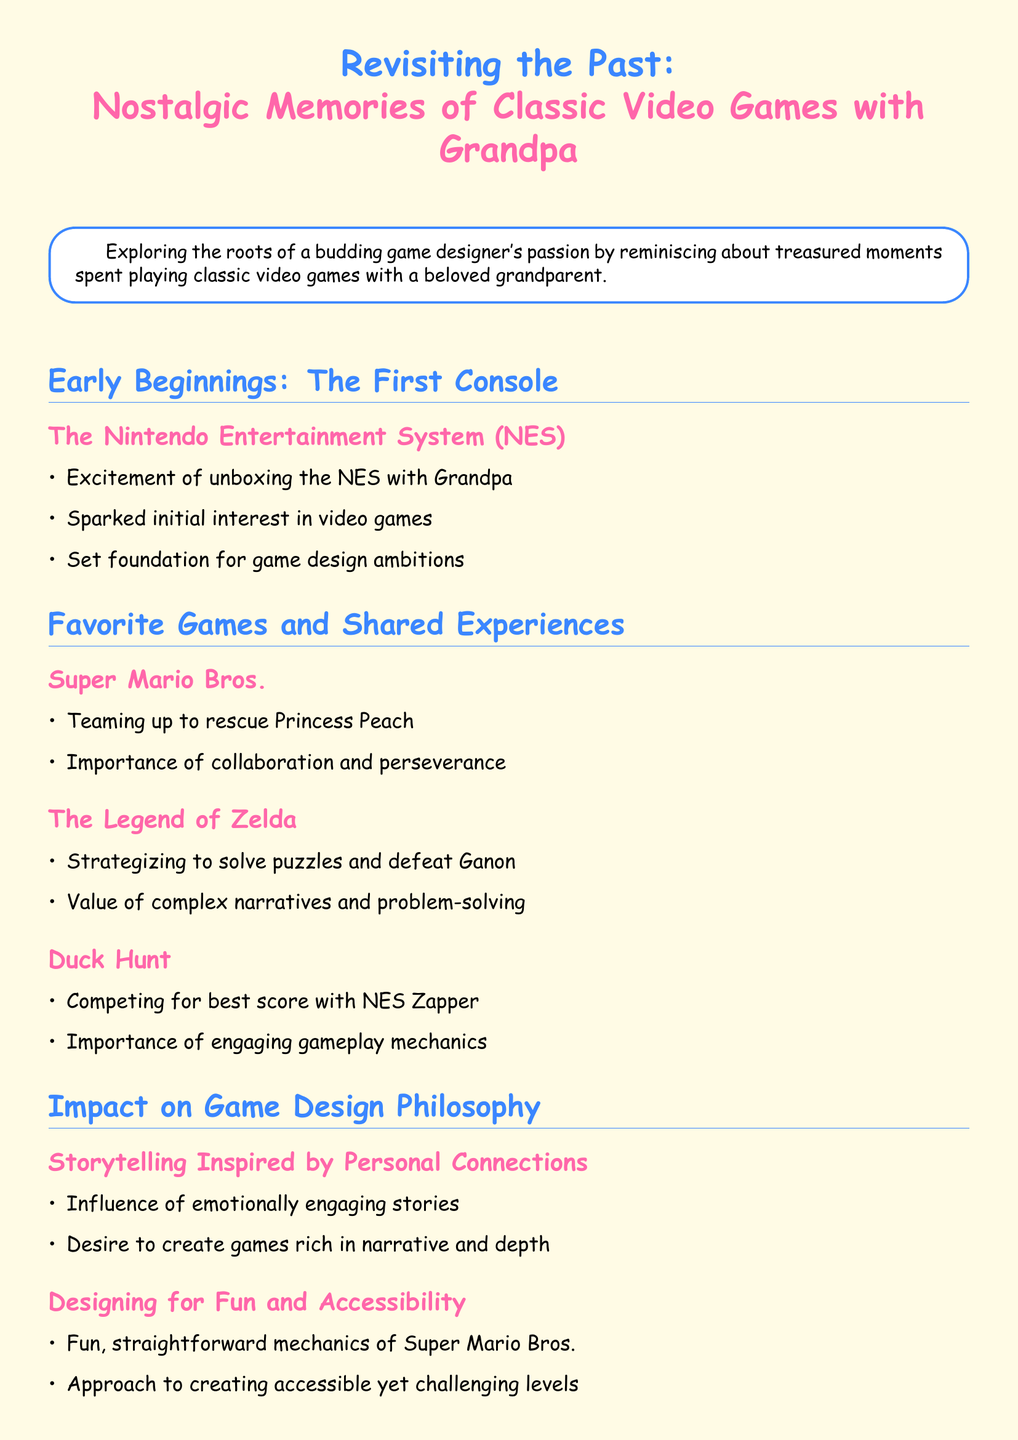What console sparked initial interest in video games? The document states that the Nintendo Entertainment System (NES) sparked initial interest in video games.
Answer: NES What game did you team up with Grandpa to rescue Princess Peach? The document mentions that Super Mario Bros. was the game played to rescue Princess Peach.
Answer: Super Mario Bros What does the document identify as a value of The Legend of Zelda? The document lists the value of complex narratives and problem-solving as a key takeaway from The Legend of Zelda.
Answer: Complex narratives and problem-solving What engaging gameplay mechanics game was played with the NES Zapper? The document refers to Duck Hunt as the game played with the NES Zapper.
Answer: Duck Hunt What is one aspect of the game design philosophy mentioned in the document? The document states the desire to create games rich in narrative and depth as an aspect of game design philosophy.
Answer: Narrative and depth Which classic game is noted for its straightforward mechanics? The document highlights Super Mario Bros. for its fun, straightforward mechanics.
Answer: Super Mario Bros What generation aspect does the document mention in designing games? The document mentions linking generations through shared experiences as an aspect of designing games.
Answer: Linking generations What is emphasized in the conclusion regarding Grandpa? The conclusion emphasizes heartfelt thanks to Grandpa for nurturing a lifelong love of games.
Answer: Thanks to Grandpa 